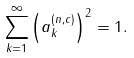<formula> <loc_0><loc_0><loc_500><loc_500>\sum _ { k = 1 } ^ { \infty } \left ( a _ { k } ^ { ( n , c ) } \right ) ^ { 2 } = 1 .</formula> 